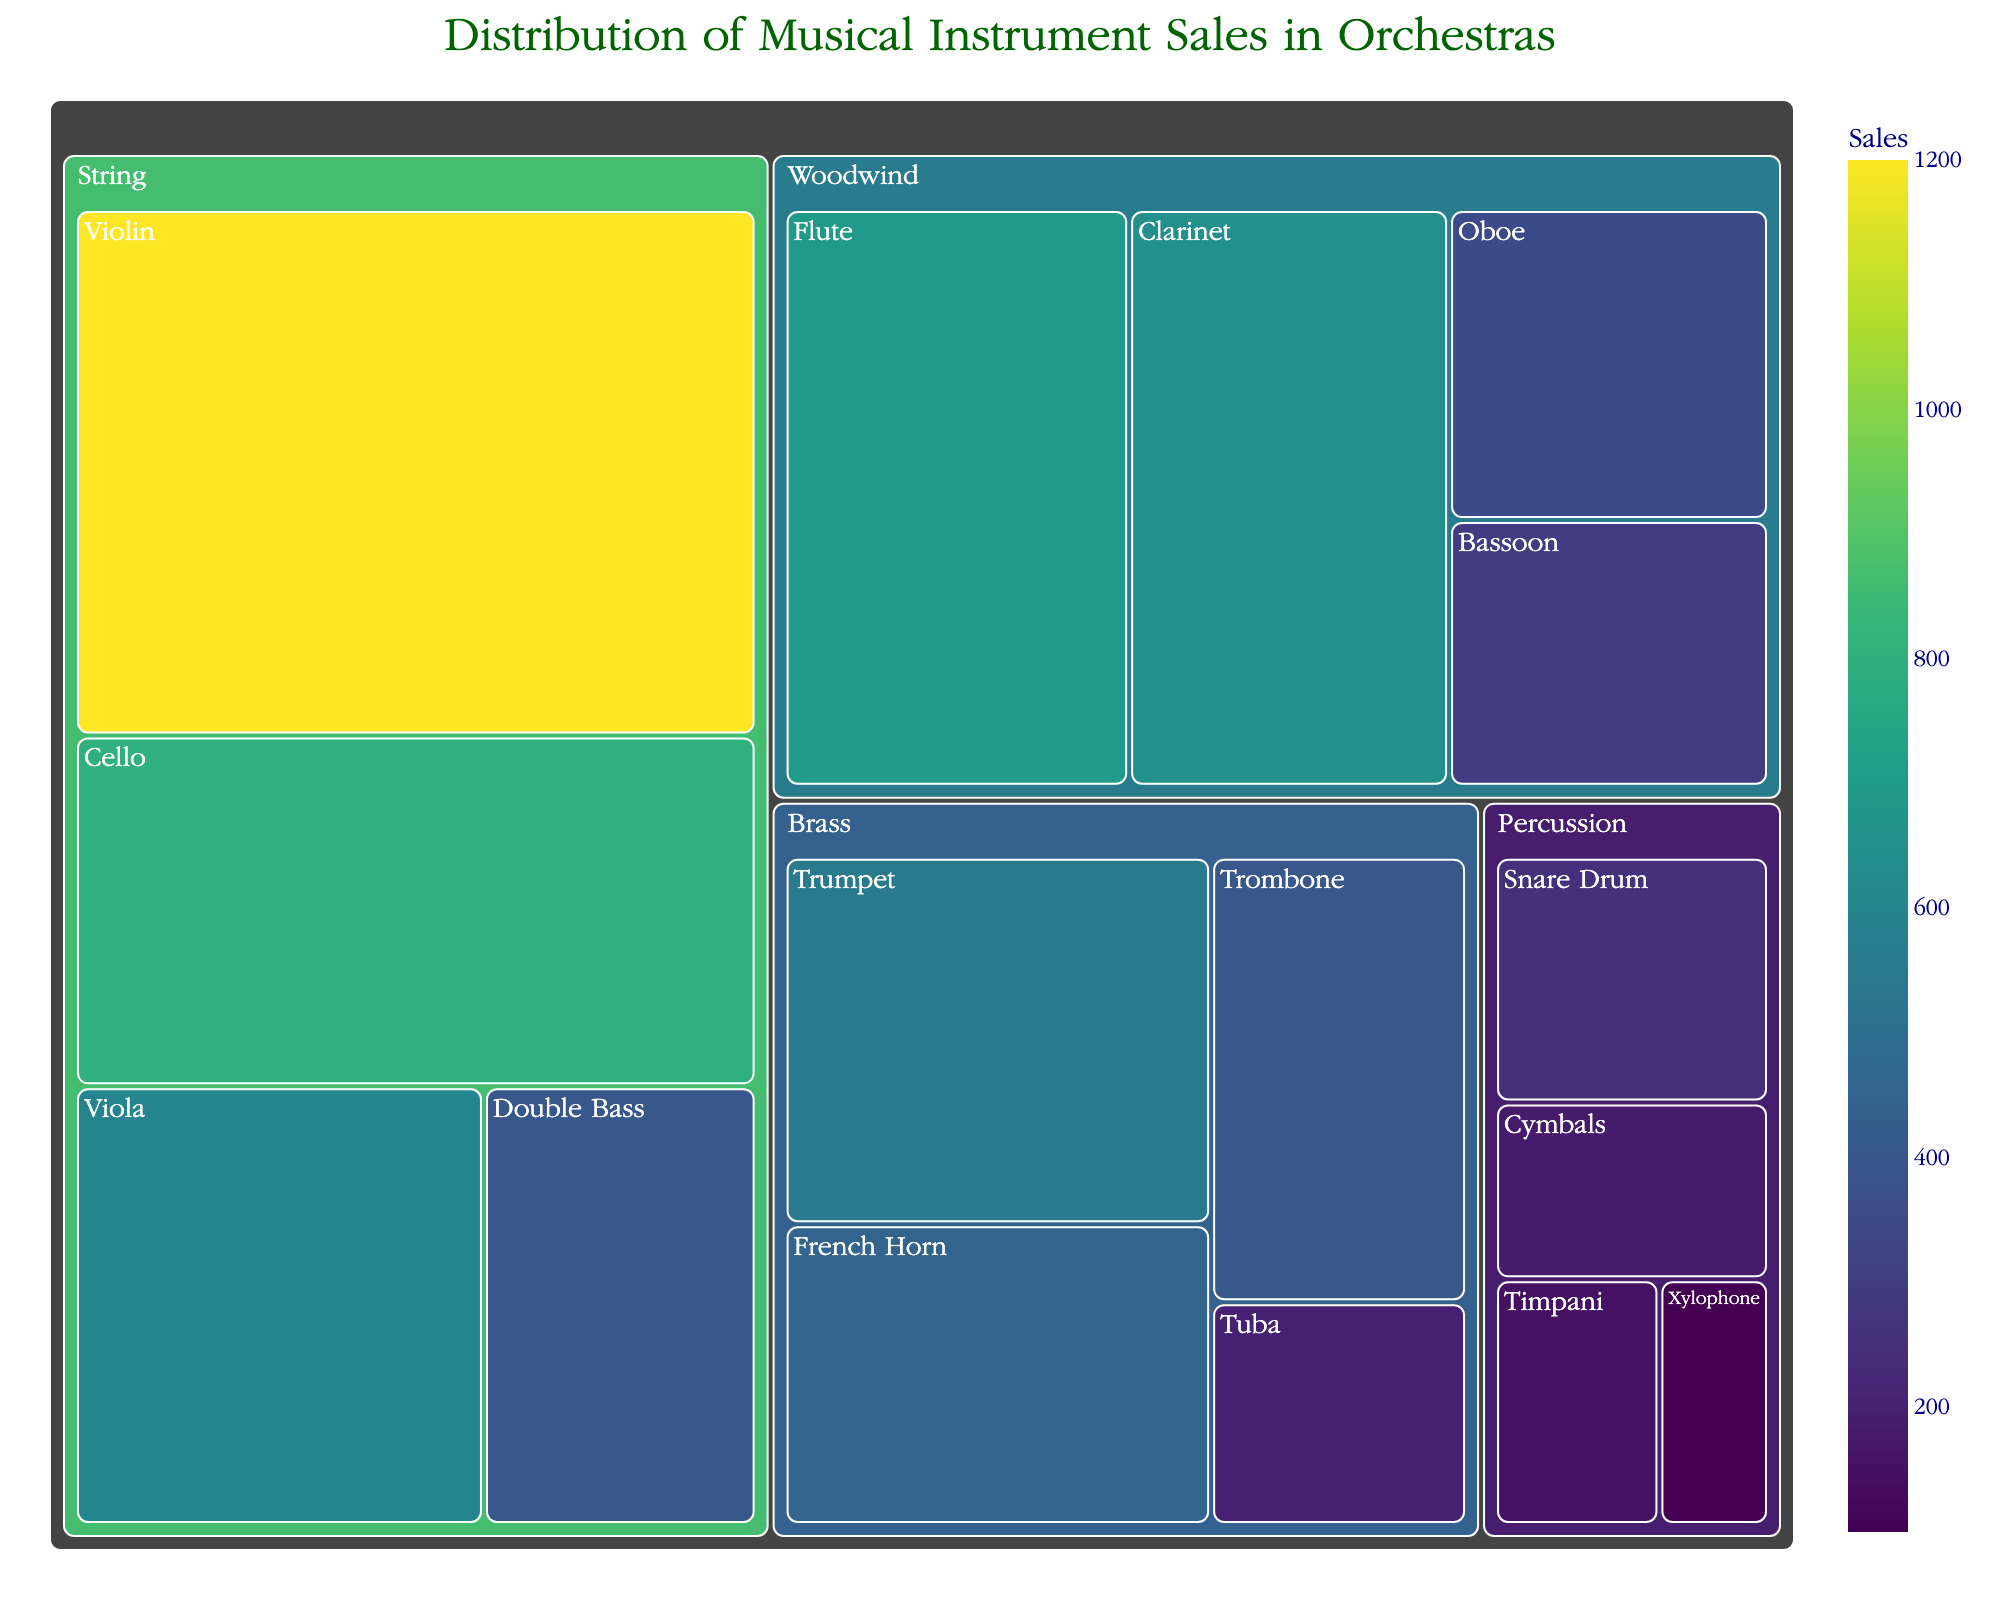What is the title of the treemap? The title is displayed prominently at the top of the treemap's layout and provides a description of what the chart represents.
Answer: Distribution of Musical Instrument Sales in Orchestras Which instrument family has the highest total sales? Identify the largest block in the treemap based on the total area occupied within the instrument families. The String family has the largest area, indicating the highest total sales.
Answer: String What is the total sales figure for the Woodwind instruments? Locate and sum the sales figures for all instruments in the Woodwind family: Flute (700), Oboe (350), Clarinet (650), and Bassoon (300). Summing these values: 700 + 350 + 650 + 300 = 2000.
Answer: 2000 How do the sales of Timpani compare to Snare Drum within the Percussion family? Compare the area of Timpani and Snare Drum blocks within the Percussion family. Look at their respective sales values: Timpani (150) and Snare Drum (250). By comparing these two values directly, Snare Drum sells more.
Answer: Snare Drum sells more Which individual instrument has the lowest sales? Identify the smallest block in the treemap, which indicates the lowest sales figure. The Xylophone in the Percussion family has the smallest area with the lowest sales figure of 100.
Answer: Xylophone What is the combined sales of Brass instruments? Sum the sales figures for all instruments in the Brass family: Trumpet (550), French Horn (450), Trombone (400), and Tuba (200). Summing these values: 550 + 450 + 400 + 200 = 1600.
Answer: 1600 What is the median sales value of all instruments in the dataset? List the sales values in ascending order: 100, 150, 180, 200, 250, 300, 350, 400, 400, 450, 550, 600, 650, 700, 800, 1200. The median is the middle value. With 16 values, the median is the average of the 8th and 9th values: (400 + 400) / 2 = 400.
Answer: 400 Which is the most popular instrument within the String family? Within the String family, look at the individual instruments and their sales. The Violin has the largest area among them with sales of 1200.
Answer: Violin How many instrument families have total sales greater than 1500? Calculate the total sales for each family and compare to 1500. String (3000), Woodwind (2000), Brass (1600), and Percussion (680). String, Woodwind, and Brass each have total sales exceeding 1500.
Answer: 3 